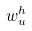Convert formula to latex. <formula><loc_0><loc_0><loc_500><loc_500>w _ { u } ^ { h }</formula> 